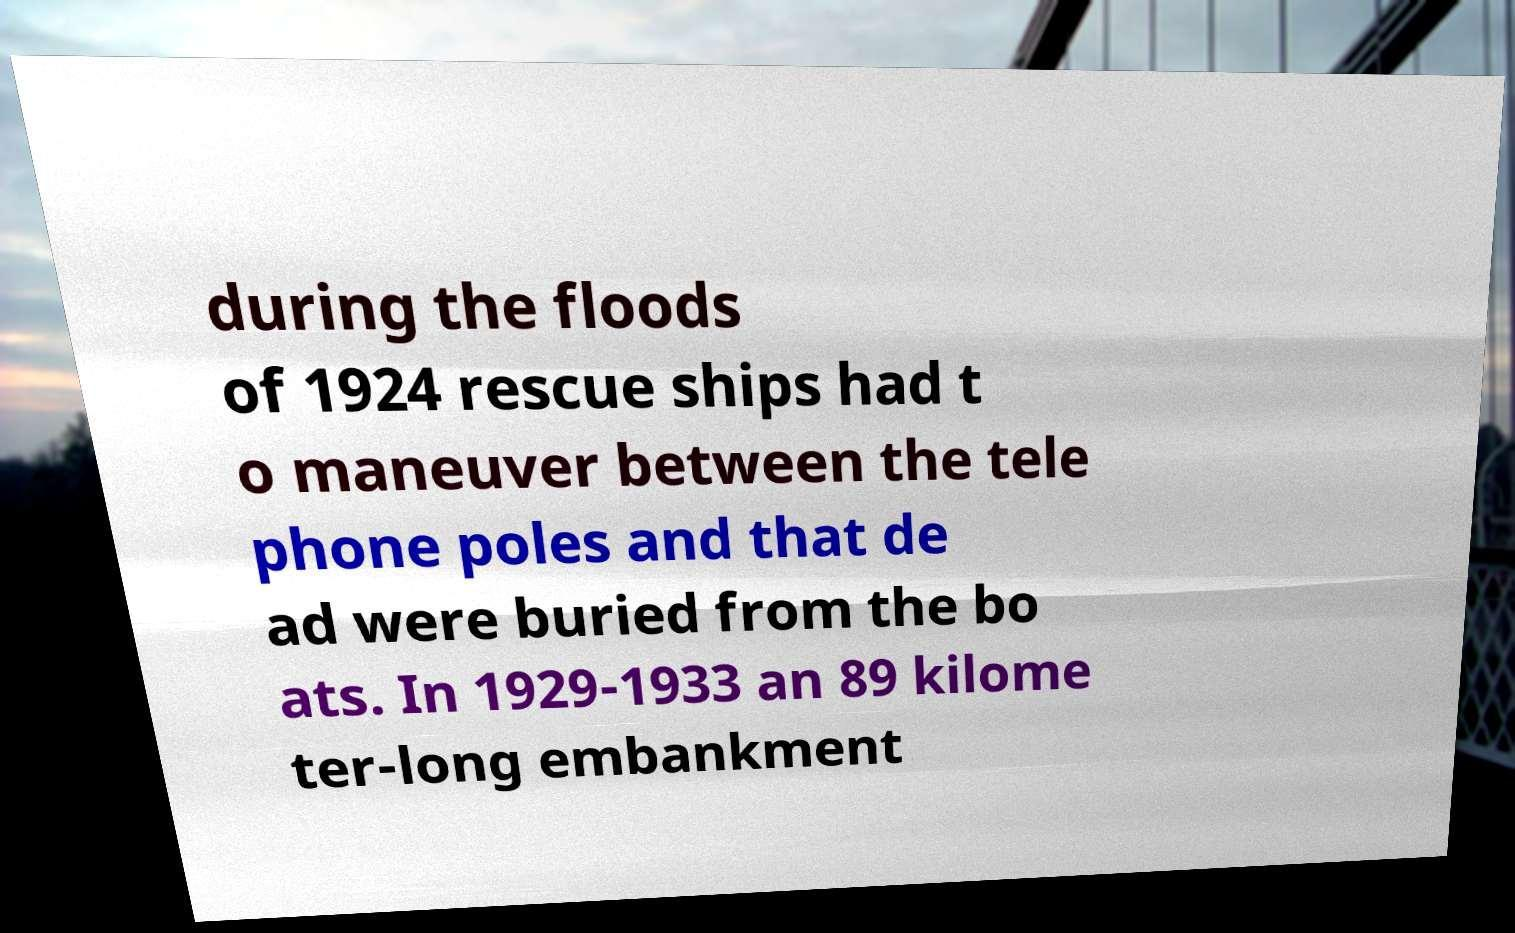Please identify and transcribe the text found in this image. during the floods of 1924 rescue ships had t o maneuver between the tele phone poles and that de ad were buried from the bo ats. In 1929-1933 an 89 kilome ter-long embankment 